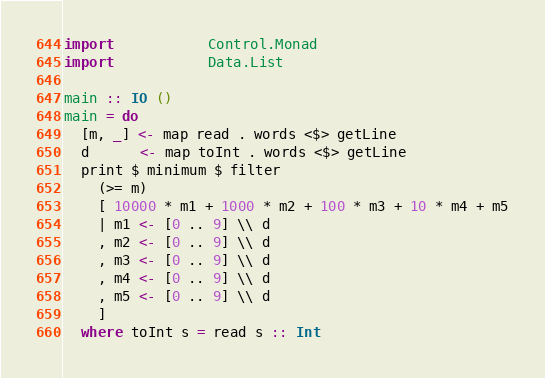<code> <loc_0><loc_0><loc_500><loc_500><_Haskell_>import           Control.Monad
import           Data.List

main :: IO ()
main = do
  [m, _] <- map read . words <$> getLine
  d      <- map toInt . words <$> getLine
  print $ minimum $ filter
    (>= m)
    [ 10000 * m1 + 1000 * m2 + 100 * m3 + 10 * m4 + m5
    | m1 <- [0 .. 9] \\ d
    , m2 <- [0 .. 9] \\ d
    , m3 <- [0 .. 9] \\ d
    , m4 <- [0 .. 9] \\ d
    , m5 <- [0 .. 9] \\ d
    ]
  where toInt s = read s :: Int
</code> 